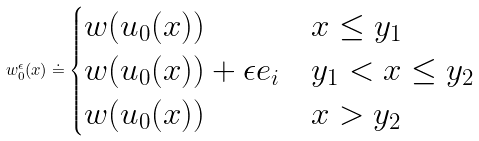Convert formula to latex. <formula><loc_0><loc_0><loc_500><loc_500>w _ { 0 } ^ { \epsilon } ( x ) \doteq \begin{cases} w ( u _ { 0 } ( x ) ) & x \leq y _ { 1 } \\ w ( u _ { 0 } ( x ) ) + \epsilon e _ { i } & y _ { 1 } < x \leq y _ { 2 } \\ w ( u _ { 0 } ( x ) ) & x > y _ { 2 } \end{cases}</formula> 